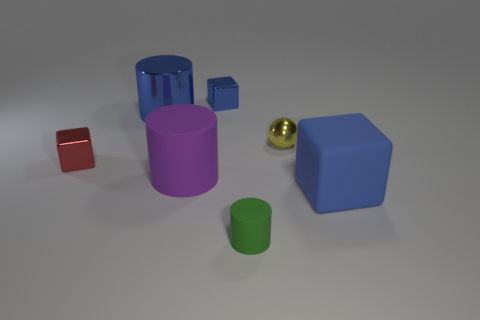Add 2 things. How many objects exist? 9 Subtract all balls. How many objects are left? 6 Subtract all blue rubber spheres. Subtract all blocks. How many objects are left? 4 Add 7 shiny balls. How many shiny balls are left? 8 Add 1 small cylinders. How many small cylinders exist? 2 Subtract 0 cyan balls. How many objects are left? 7 